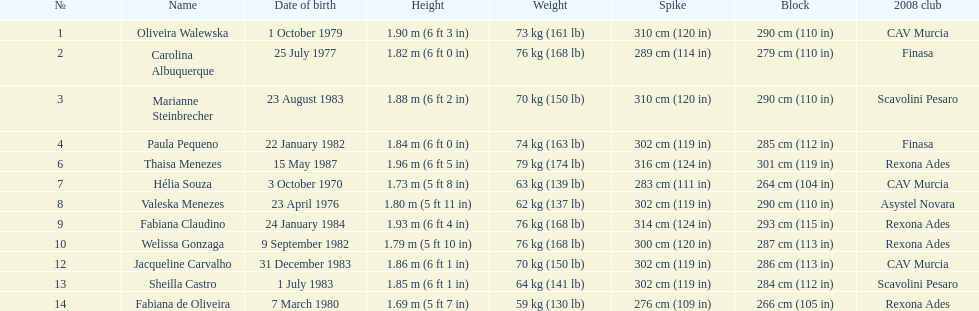What is fabiana de oliveira's weight? 76 kg (168 lb). What is helia souza's weight? 63 kg (139 lb). What is sheilla castro's weight? 64 kg (141 lb). Who did the initial inquirer mistakenly think was the heaviest (when they are actually the second heaviest)? Sheilla Castro. 